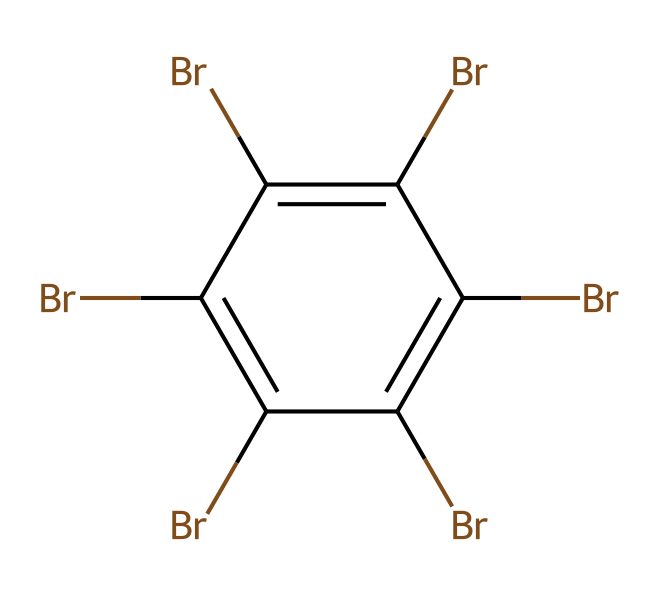What is the primary element in the chemical structure? The SMILES notation indicates the presence of bromine atoms (Br), which can be counted in the structure. In this case, there are multiple bromine atoms present.
Answer: bromine How many bromine atoms are present in this structure? By interpreting the SMILES, we can see that there are six 'Br' notations in the chemical, indicating the total count of bromine atoms.
Answer: six What type of compound is represented by this chemical? Since the structure has multiple bromine substituents on a cyclic carbon framework, it is classified as a brominated flame retardant, commonly used in electronics.
Answer: brominated flame retardant What is the overall structure type shown here? The chemical's structure is cyclic due to the 'c1' notation that indicates a ring system with alternating bromines, making it an aromatic compound.
Answer: aromatic What property do the bromine atoms impart to this chemical? Bromine atoms in the structure serve to enhance the flame retardant properties of the chemical, making it less flammable.
Answer: flame retardant Which type of bond connects the carbon atoms in this structure? The 'c' notation in the SMILES indicates that the carbon atoms are connected by carbon-carbon single bonds, typical in aromatic systems with alternating double bonds.
Answer: single bonds What visual characteristic does this structure possess? The presence of multiple bromine atoms on a carbon ring gives a heavily substituted appearance, showing it is highly chlorinated, contributing to its chemical stability in various applications.
Answer: heavily substituted 